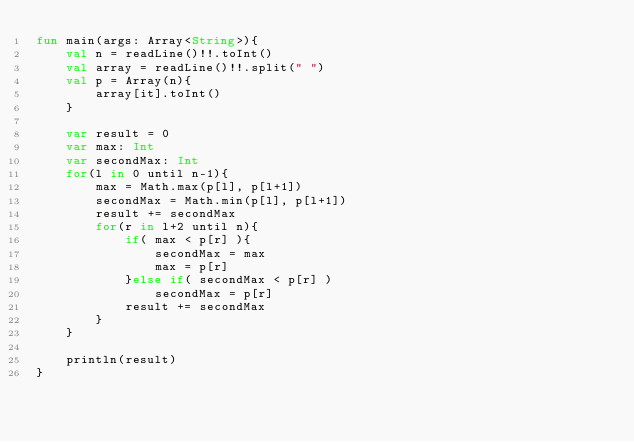<code> <loc_0><loc_0><loc_500><loc_500><_Kotlin_>fun main(args: Array<String>){
	val n = readLine()!!.toInt()
	val array = readLine()!!.split(" ")
	val p = Array(n){
		array[it].toInt()
	}
	
	var result = 0
	var max: Int
	var secondMax: Int
	for(l in 0 until n-1){
		max = Math.max(p[l], p[l+1])
		secondMax = Math.min(p[l], p[l+1])
		result += secondMax
		for(r in l+2 until n){
			if( max < p[r] ){
				secondMax = max
				max = p[r]
			}else if( secondMax < p[r] )
				secondMax = p[r]
			result += secondMax
		}
	}
	
	println(result)
}
</code> 